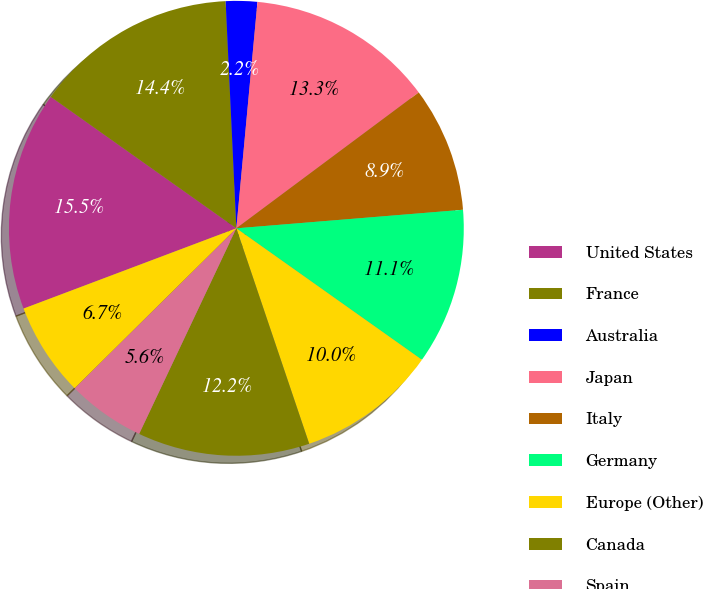<chart> <loc_0><loc_0><loc_500><loc_500><pie_chart><fcel>United States<fcel>France<fcel>Australia<fcel>Japan<fcel>Italy<fcel>Germany<fcel>Europe (Other)<fcel>Canada<fcel>Spain<fcel>Mexico<nl><fcel>15.55%<fcel>14.44%<fcel>2.23%<fcel>13.33%<fcel>8.89%<fcel>11.11%<fcel>10.0%<fcel>12.22%<fcel>5.56%<fcel>6.67%<nl></chart> 